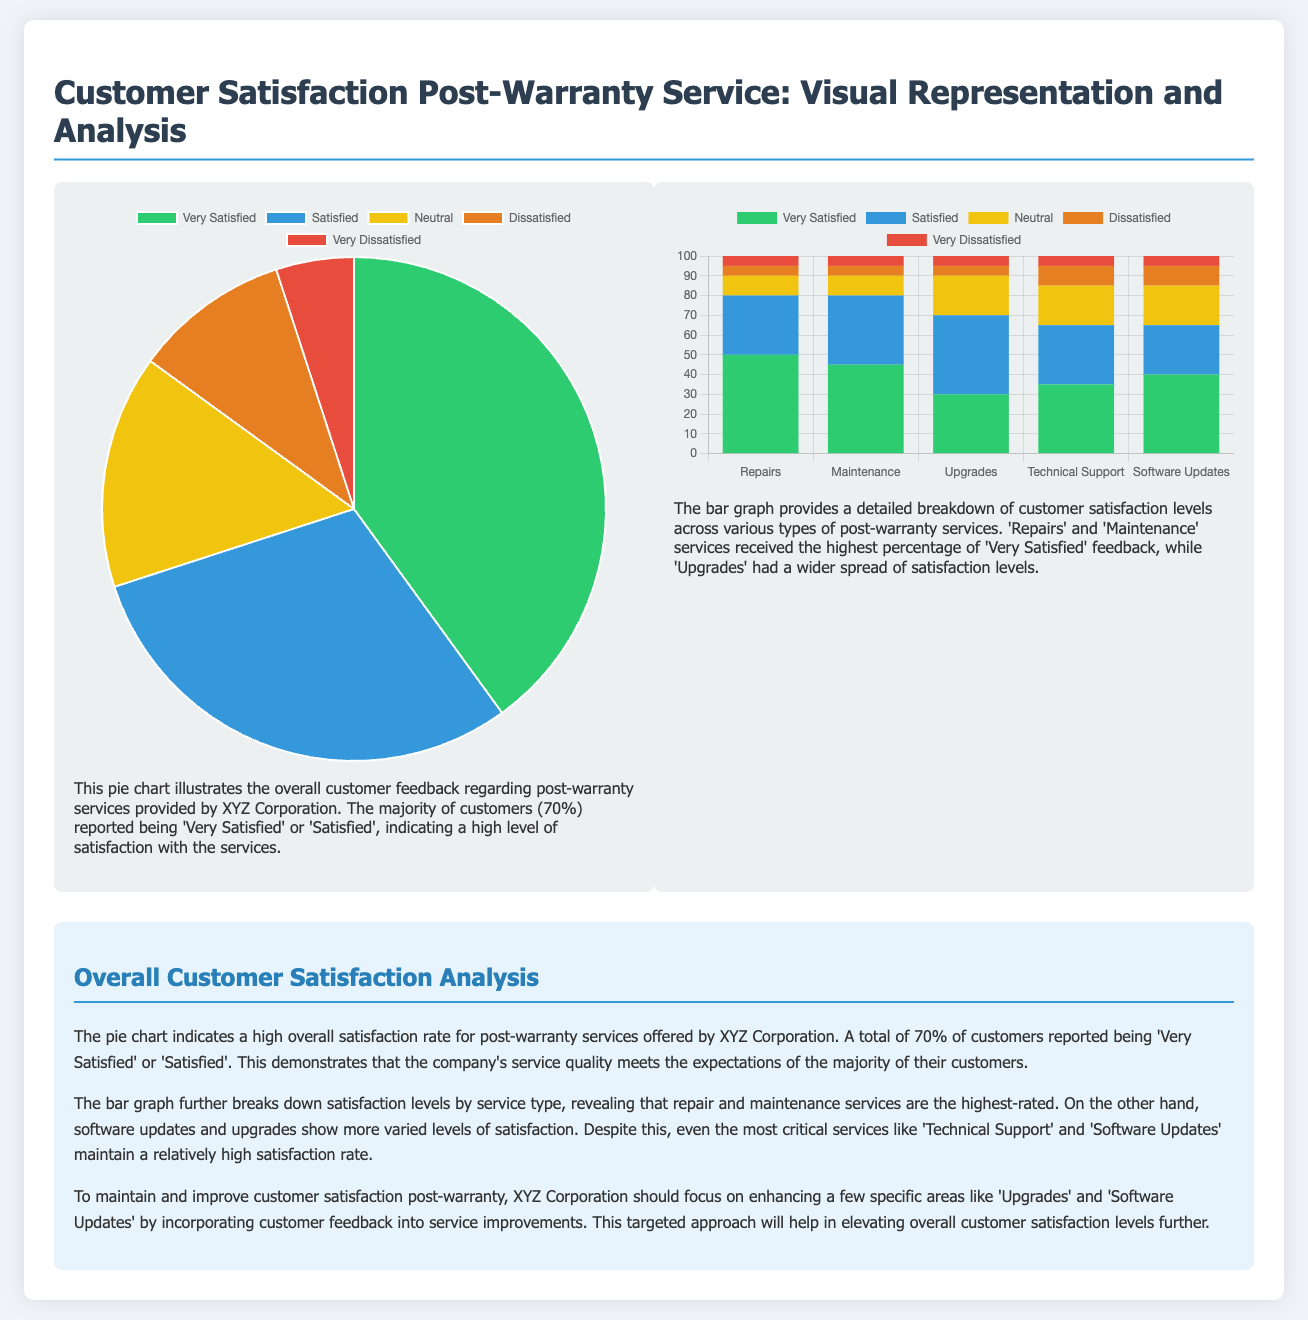What percentage of customers reported being 'Very Satisfied' post-warranty service? The pie chart indicates that 40% of customers reported being 'Very Satisfied'.
Answer: 40% How many customers reported they were 'Satisfied'? The pie chart shows that 30% of customers reported being 'Satisfied'.
Answer: 30% Which service type received the highest percentage of 'Very Satisfied' feedback? The bar graph shows that 'Repairs' received the highest percentage of 'Very Satisfied' feedback.
Answer: Repairs What is the total percentage of customers who reported 'Very Satisfied' and 'Satisfied'? Adding the percentages from the pie chart, 40% + 30% = 70% of customers reported 'Very Satisfied' or 'Satisfied'.
Answer: 70% How many service types were evaluated in the bar graph? The bar graph lists five different service types for evaluation.
Answer: Five What is the lowest satisfaction level recorded for 'Technical Support'? The bar graph indicates that 'Technical Support' has a value of 10% for 'Dissatisfied'.
Answer: 10% Which two services had the most varied levels of satisfaction according to the bar graph? The bar graph reveals that 'Upgrades' and 'Software Updates' had more varied levels of satisfaction responses.
Answer: Upgrades and Software Updates What is the overall satisfaction level reported in the analysis? The analysis indicates that 70% of customers reported either 'Very Satisfied' or 'Satisfied', showcasing high overall satisfaction.
Answer: High overall satisfaction 